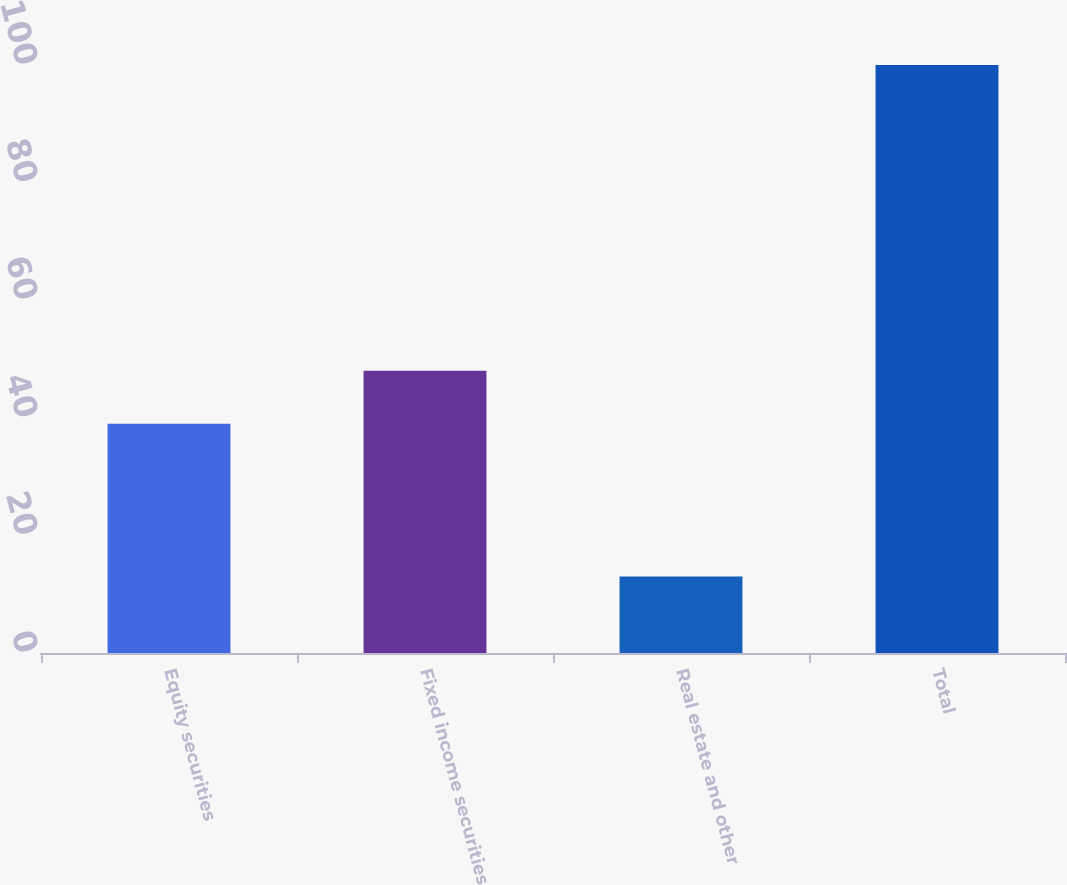Convert chart. <chart><loc_0><loc_0><loc_500><loc_500><bar_chart><fcel>Equity securities<fcel>Fixed income securities<fcel>Real estate and other<fcel>Total<nl><fcel>39<fcel>48<fcel>13<fcel>100<nl></chart> 